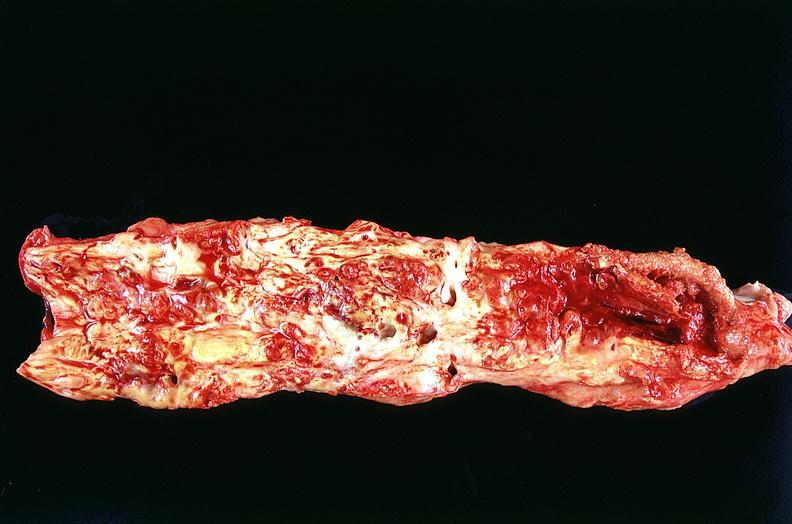does this image show aorta, abdominal?
Answer the question using a single word or phrase. Yes 